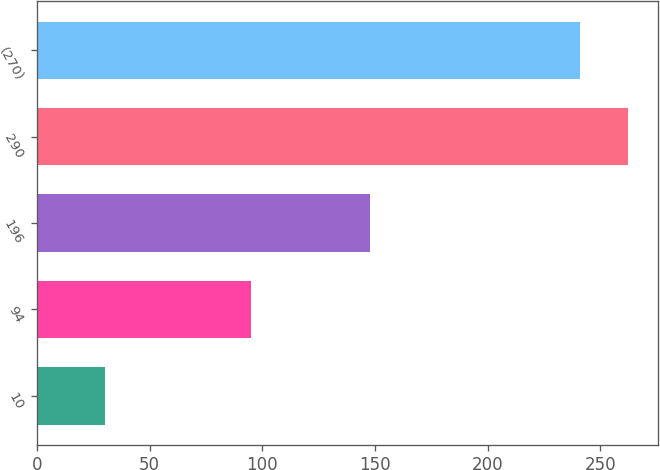Convert chart. <chart><loc_0><loc_0><loc_500><loc_500><bar_chart><fcel>10<fcel>94<fcel>196<fcel>290<fcel>(270)<nl><fcel>30<fcel>95<fcel>148<fcel>262.4<fcel>241<nl></chart> 